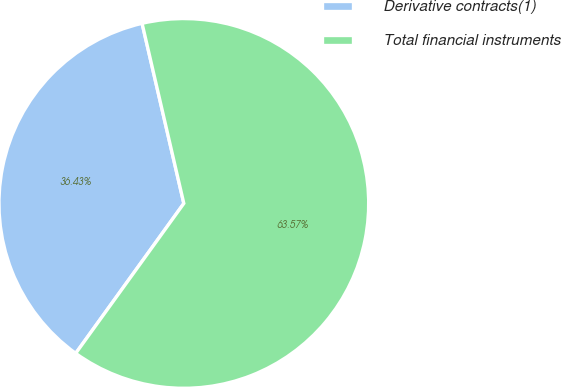<chart> <loc_0><loc_0><loc_500><loc_500><pie_chart><fcel>Derivative contracts(1)<fcel>Total financial instruments<nl><fcel>36.43%<fcel>63.57%<nl></chart> 